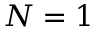<formula> <loc_0><loc_0><loc_500><loc_500>N = 1</formula> 